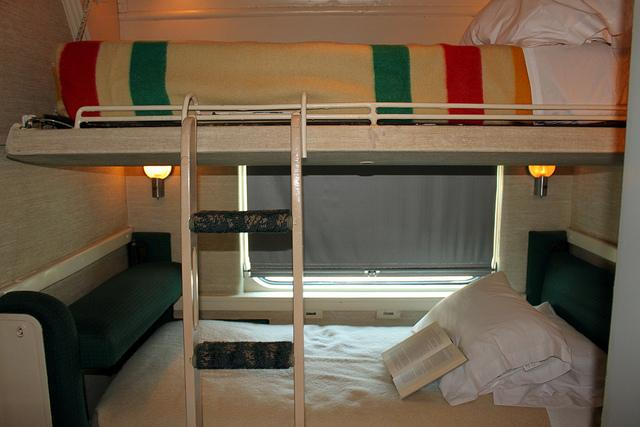Where might these sleeping quarters be located? train 